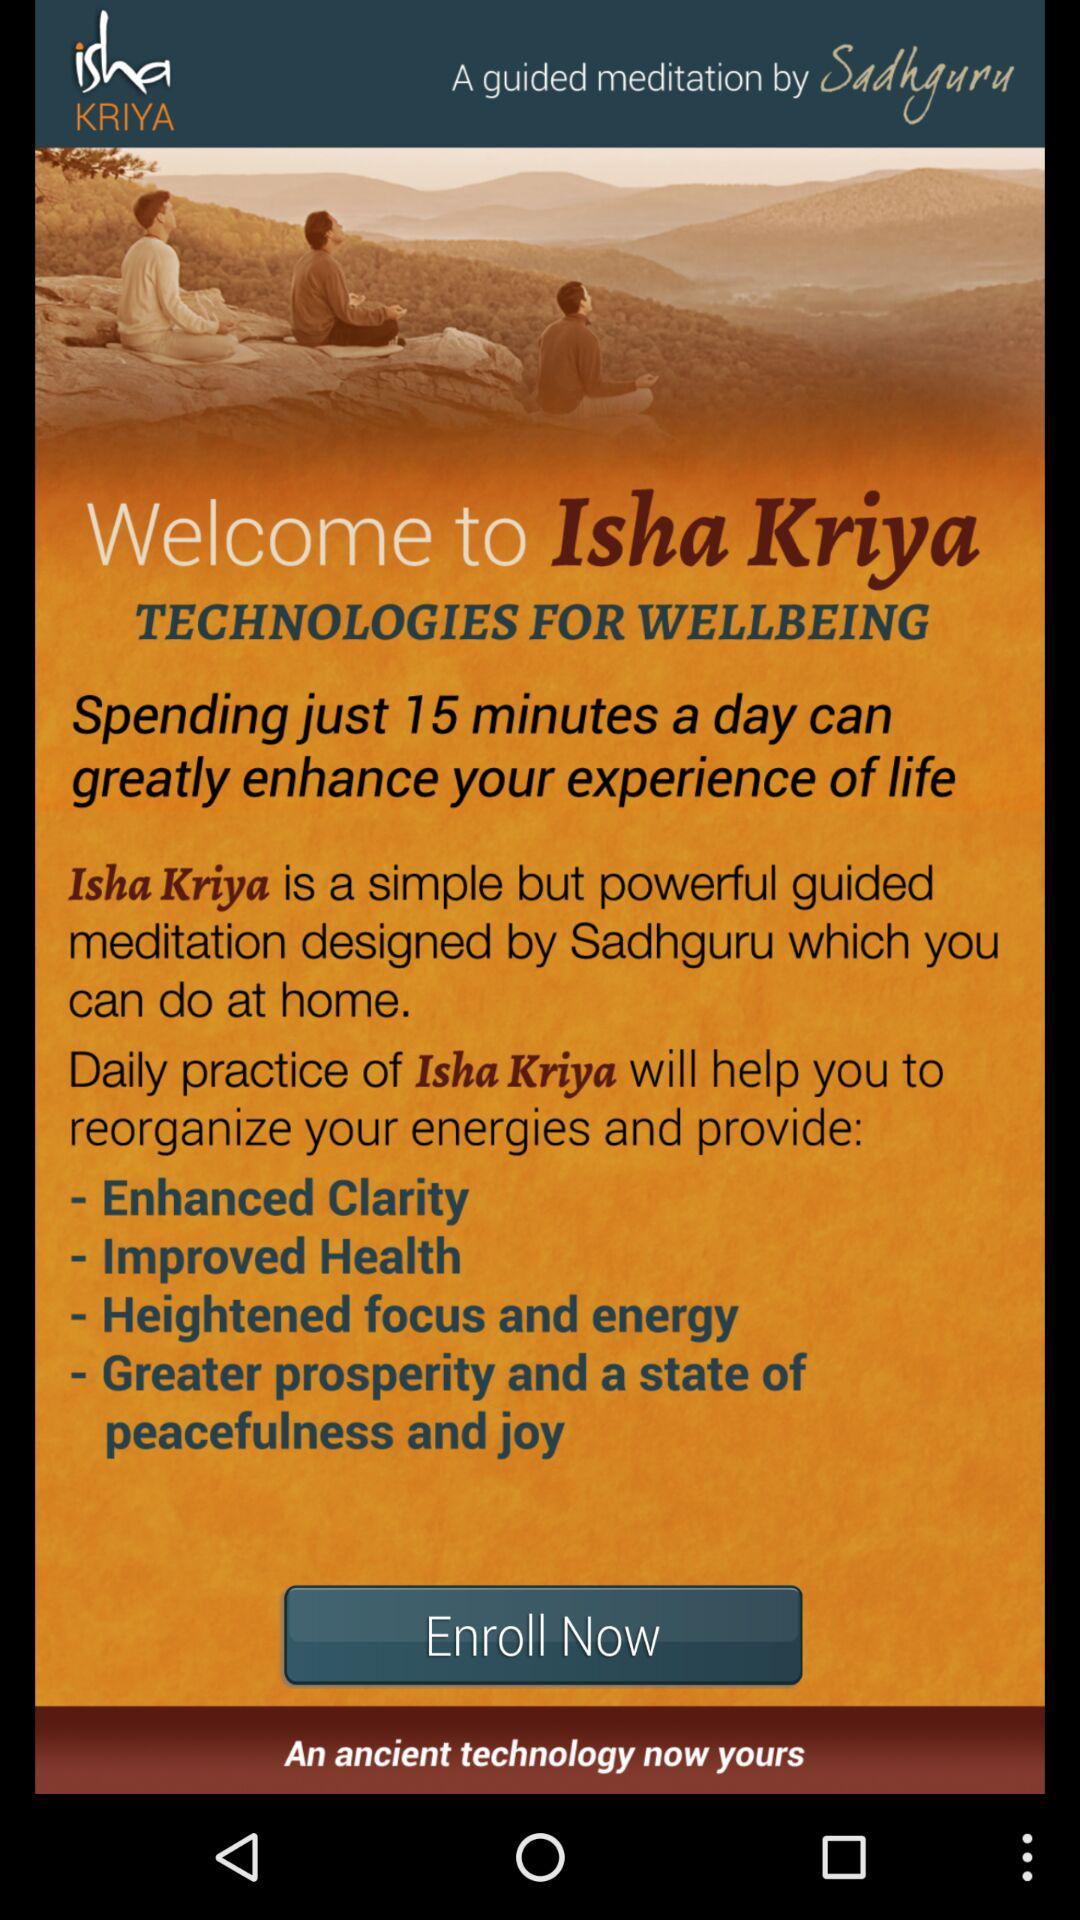Spending just how many minutes a day greatly enhances my experience of life? You can greatly enhance your life by spending 15 minutes a day on it. 